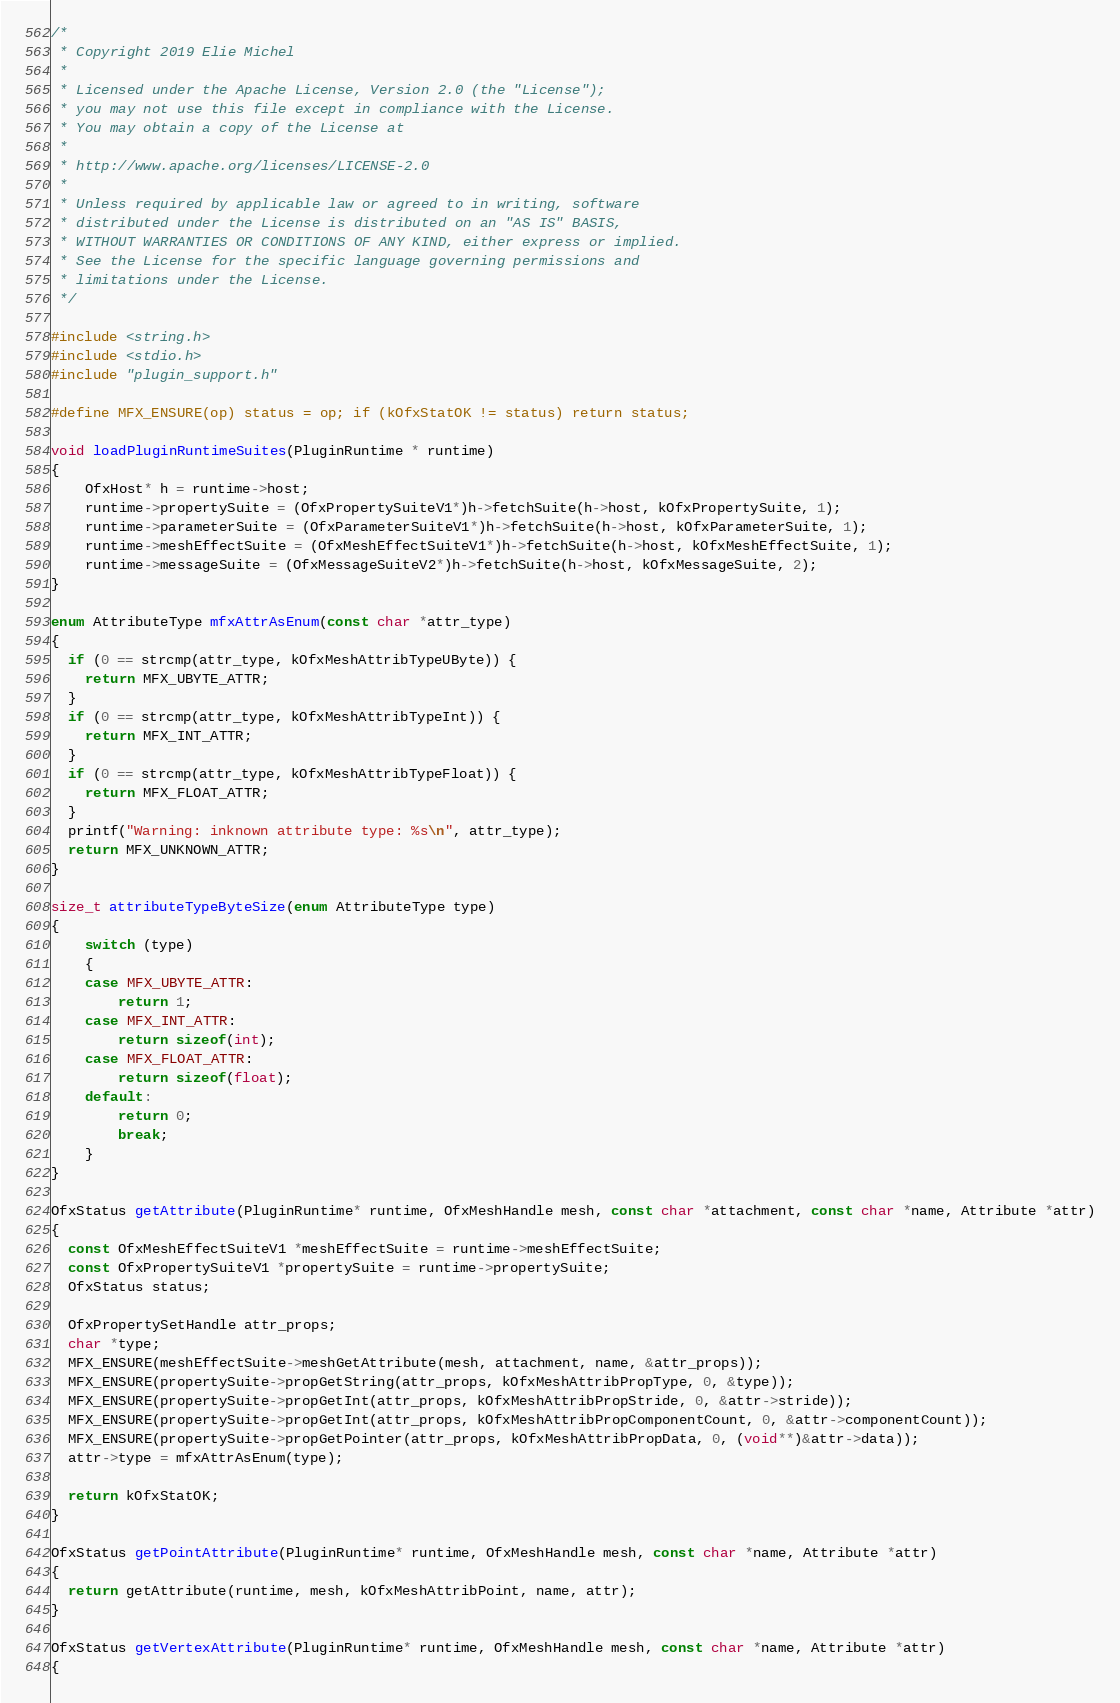<code> <loc_0><loc_0><loc_500><loc_500><_C_>/*
 * Copyright 2019 Elie Michel
 *
 * Licensed under the Apache License, Version 2.0 (the "License");
 * you may not use this file except in compliance with the License.
 * You may obtain a copy of the License at
 *
 * http://www.apache.org/licenses/LICENSE-2.0
 *
 * Unless required by applicable law or agreed to in writing, software
 * distributed under the License is distributed on an "AS IS" BASIS,
 * WITHOUT WARRANTIES OR CONDITIONS OF ANY KIND, either express or implied.
 * See the License for the specific language governing permissions and
 * limitations under the License.
 */

#include <string.h>
#include <stdio.h>
#include "plugin_support.h"

#define MFX_ENSURE(op) status = op; if (kOfxStatOK != status) return status;

void loadPluginRuntimeSuites(PluginRuntime * runtime)
{
    OfxHost* h = runtime->host;
    runtime->propertySuite = (OfxPropertySuiteV1*)h->fetchSuite(h->host, kOfxPropertySuite, 1);
    runtime->parameterSuite = (OfxParameterSuiteV1*)h->fetchSuite(h->host, kOfxParameterSuite, 1);
    runtime->meshEffectSuite = (OfxMeshEffectSuiteV1*)h->fetchSuite(h->host, kOfxMeshEffectSuite, 1);
    runtime->messageSuite = (OfxMessageSuiteV2*)h->fetchSuite(h->host, kOfxMessageSuite, 2);
}

enum AttributeType mfxAttrAsEnum(const char *attr_type)
{
  if (0 == strcmp(attr_type, kOfxMeshAttribTypeUByte)) {
    return MFX_UBYTE_ATTR;
  }
  if (0 == strcmp(attr_type, kOfxMeshAttribTypeInt)) {
    return MFX_INT_ATTR;
  }
  if (0 == strcmp(attr_type, kOfxMeshAttribTypeFloat)) {
    return MFX_FLOAT_ATTR;
  }
  printf("Warning: inknown attribute type: %s\n", attr_type);
  return MFX_UNKNOWN_ATTR;
}

size_t attributeTypeByteSize(enum AttributeType type)
{
    switch (type)
    {
    case MFX_UBYTE_ATTR:
        return 1;
    case MFX_INT_ATTR:
        return sizeof(int);
    case MFX_FLOAT_ATTR:
        return sizeof(float);
    default:
        return 0;
        break;
    }
}

OfxStatus getAttribute(PluginRuntime* runtime, OfxMeshHandle mesh, const char *attachment, const char *name, Attribute *attr)
{
  const OfxMeshEffectSuiteV1 *meshEffectSuite = runtime->meshEffectSuite;
  const OfxPropertySuiteV1 *propertySuite = runtime->propertySuite;
  OfxStatus status;

  OfxPropertySetHandle attr_props;
  char *type;
  MFX_ENSURE(meshEffectSuite->meshGetAttribute(mesh, attachment, name, &attr_props));
  MFX_ENSURE(propertySuite->propGetString(attr_props, kOfxMeshAttribPropType, 0, &type));
  MFX_ENSURE(propertySuite->propGetInt(attr_props, kOfxMeshAttribPropStride, 0, &attr->stride));
  MFX_ENSURE(propertySuite->propGetInt(attr_props, kOfxMeshAttribPropComponentCount, 0, &attr->componentCount));
  MFX_ENSURE(propertySuite->propGetPointer(attr_props, kOfxMeshAttribPropData, 0, (void**)&attr->data));
  attr->type = mfxAttrAsEnum(type);

  return kOfxStatOK;
}

OfxStatus getPointAttribute(PluginRuntime* runtime, OfxMeshHandle mesh, const char *name, Attribute *attr)
{
  return getAttribute(runtime, mesh, kOfxMeshAttribPoint, name, attr);
}

OfxStatus getVertexAttribute(PluginRuntime* runtime, OfxMeshHandle mesh, const char *name, Attribute *attr)
{</code> 